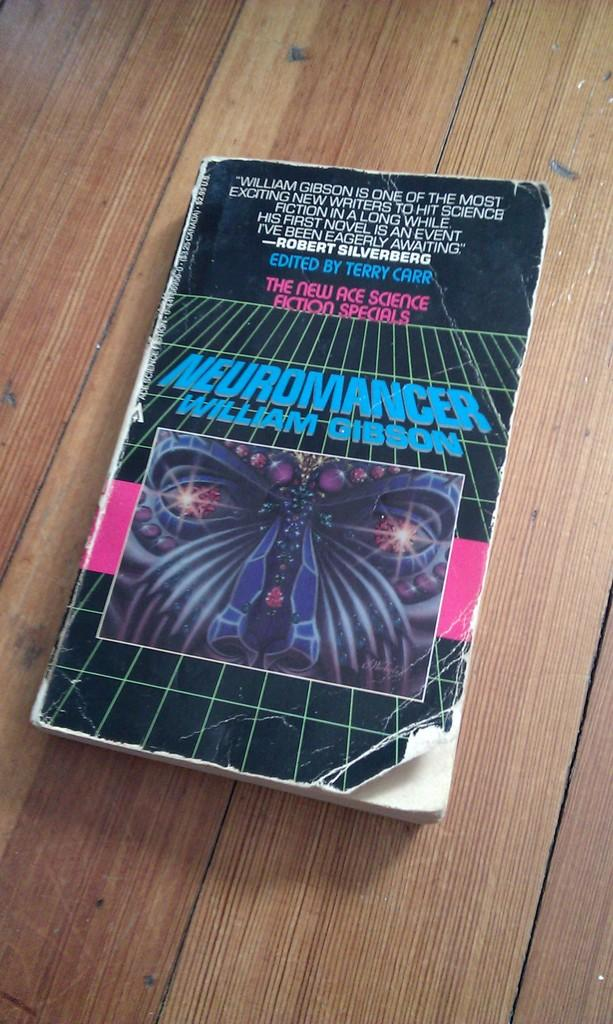<image>
Share a concise interpretation of the image provided. A paperback copy of Necromancer by William Gibson sits on a wooden table. 